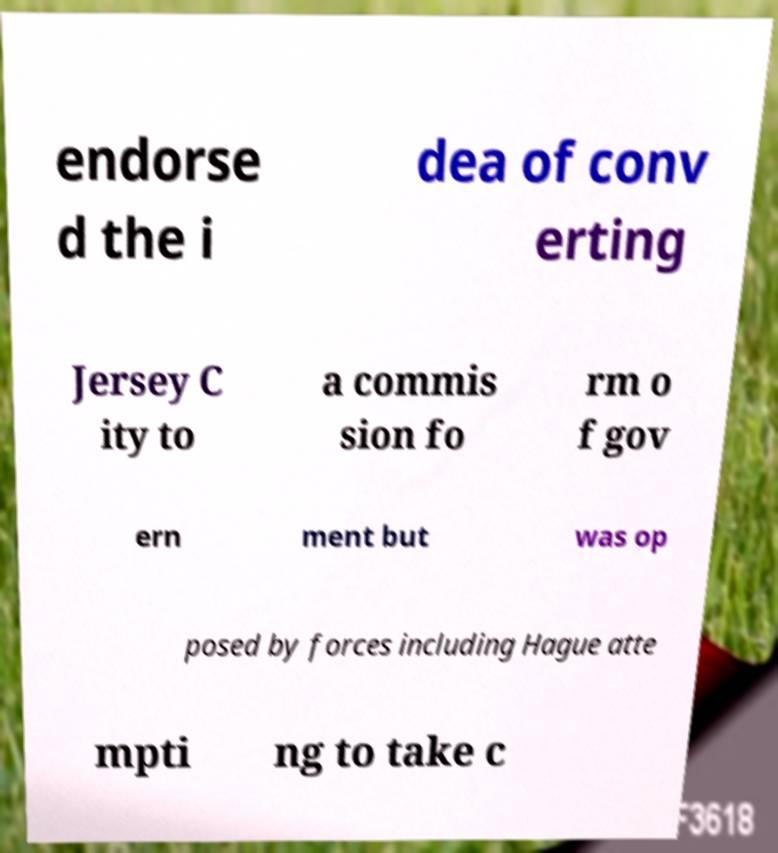Could you extract and type out the text from this image? endorse d the i dea of conv erting Jersey C ity to a commis sion fo rm o f gov ern ment but was op posed by forces including Hague atte mpti ng to take c 